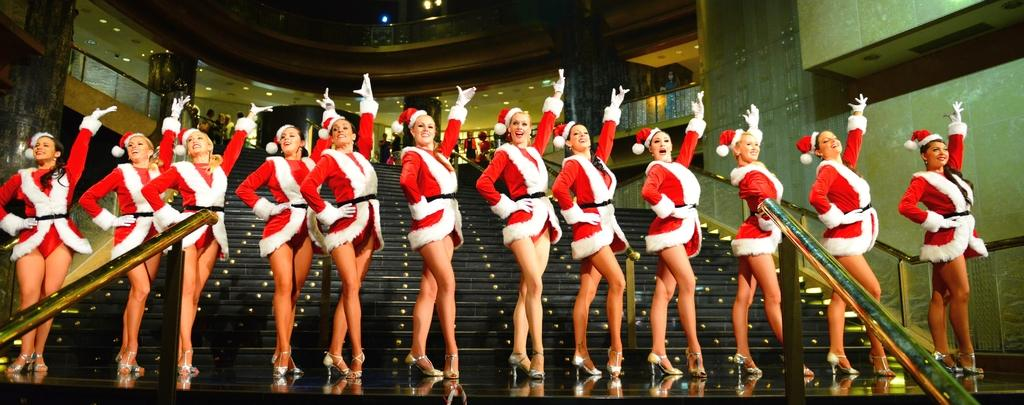Who is present in the image? There are women in the image. What are the women doing in the image? The women are standing and showing a gesture. What can be seen in the background of the image? There are steps of a building in the background. What else is visible in the image? There is a crowd visible at the top of the image. What type of jam is being served to the crowd in the image? There is no jam present in the image; it features women standing and showing a gesture, with a crowd visible at the top of the image. What grade are the women in the image? The provided facts do not mention any information about the women's grade or age. 